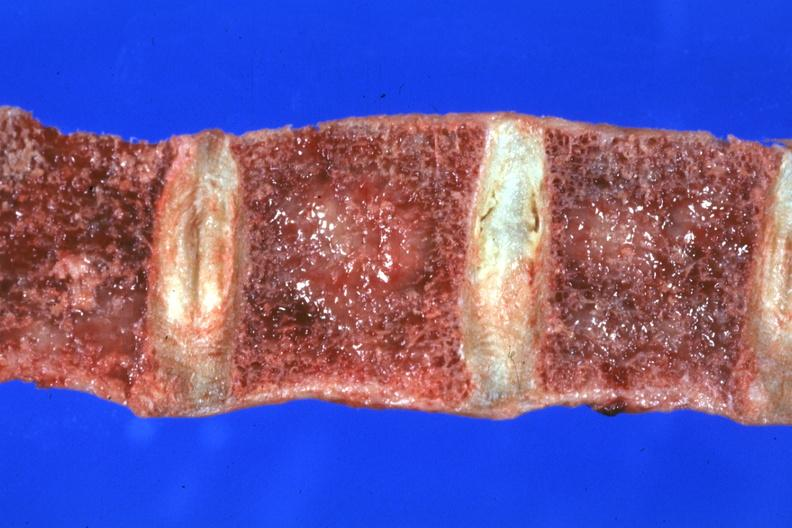s cut surface both testicles on normal and one quite small typical probably due to mumps present?
Answer the question using a single word or phrase. No 